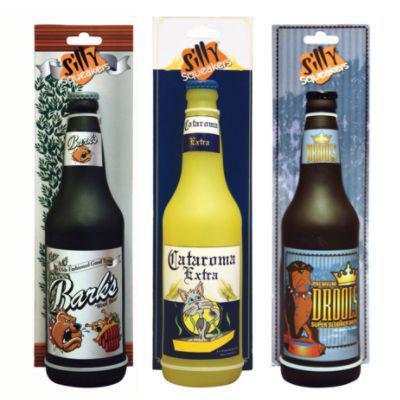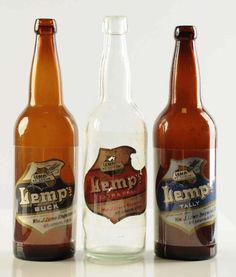The first image is the image on the left, the second image is the image on the right. For the images shown, is this caption "There are no more than five beer bottles" true? Answer yes or no. No. The first image is the image on the left, the second image is the image on the right. Examine the images to the left and right. Is the description "Right and left images show the same number of bottles." accurate? Answer yes or no. Yes. 